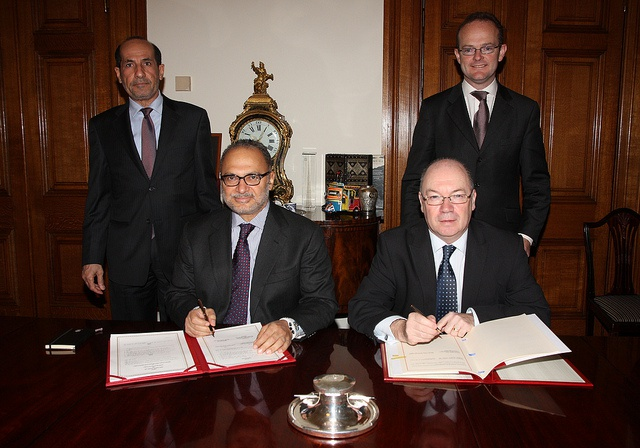Describe the objects in this image and their specific colors. I can see people in black, maroon, brown, and gray tones, people in black, lightpink, lightgray, and gray tones, people in black, brown, and tan tones, people in black, brown, maroon, and gray tones, and book in black, lightgray, brown, and darkgray tones in this image. 